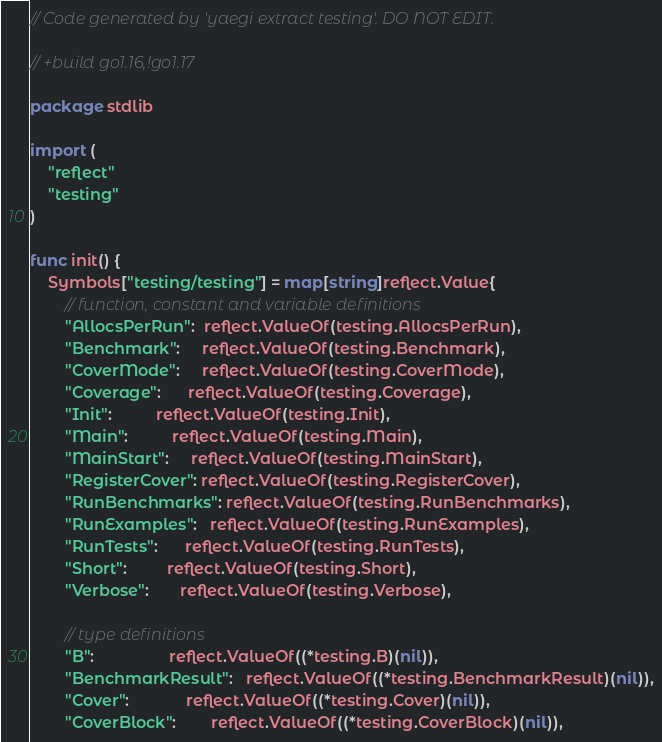Convert code to text. <code><loc_0><loc_0><loc_500><loc_500><_Go_>// Code generated by 'yaegi extract testing'. DO NOT EDIT.

// +build go1.16,!go1.17

package stdlib

import (
	"reflect"
	"testing"
)

func init() {
	Symbols["testing/testing"] = map[string]reflect.Value{
		// function, constant and variable definitions
		"AllocsPerRun":  reflect.ValueOf(testing.AllocsPerRun),
		"Benchmark":     reflect.ValueOf(testing.Benchmark),
		"CoverMode":     reflect.ValueOf(testing.CoverMode),
		"Coverage":      reflect.ValueOf(testing.Coverage),
		"Init":          reflect.ValueOf(testing.Init),
		"Main":          reflect.ValueOf(testing.Main),
		"MainStart":     reflect.ValueOf(testing.MainStart),
		"RegisterCover": reflect.ValueOf(testing.RegisterCover),
		"RunBenchmarks": reflect.ValueOf(testing.RunBenchmarks),
		"RunExamples":   reflect.ValueOf(testing.RunExamples),
		"RunTests":      reflect.ValueOf(testing.RunTests),
		"Short":         reflect.ValueOf(testing.Short),
		"Verbose":       reflect.ValueOf(testing.Verbose),

		// type definitions
		"B":                 reflect.ValueOf((*testing.B)(nil)),
		"BenchmarkResult":   reflect.ValueOf((*testing.BenchmarkResult)(nil)),
		"Cover":             reflect.ValueOf((*testing.Cover)(nil)),
		"CoverBlock":        reflect.ValueOf((*testing.CoverBlock)(nil)),</code> 